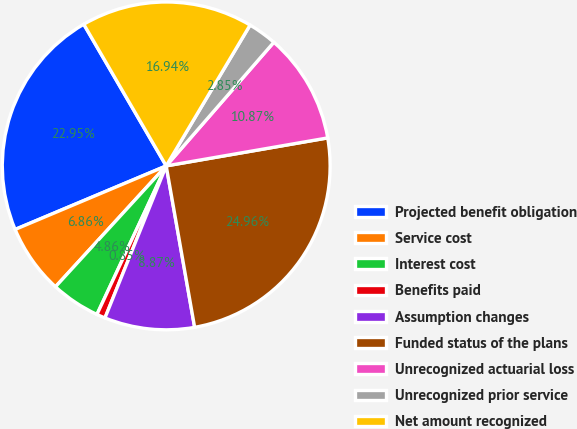Convert chart to OTSL. <chart><loc_0><loc_0><loc_500><loc_500><pie_chart><fcel>Projected benefit obligation<fcel>Service cost<fcel>Interest cost<fcel>Benefits paid<fcel>Assumption changes<fcel>Funded status of the plans<fcel>Unrecognized actuarial loss<fcel>Unrecognized prior service<fcel>Net amount recognized<nl><fcel>22.95%<fcel>6.86%<fcel>4.86%<fcel>0.85%<fcel>8.87%<fcel>24.96%<fcel>10.87%<fcel>2.85%<fcel>16.94%<nl></chart> 